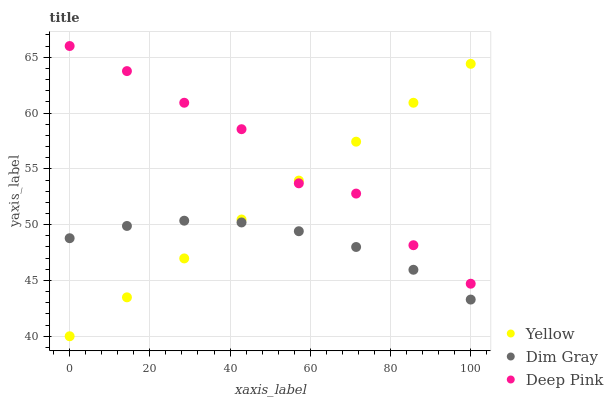Does Dim Gray have the minimum area under the curve?
Answer yes or no. Yes. Does Deep Pink have the maximum area under the curve?
Answer yes or no. Yes. Does Yellow have the minimum area under the curve?
Answer yes or no. No. Does Yellow have the maximum area under the curve?
Answer yes or no. No. Is Yellow the smoothest?
Answer yes or no. Yes. Is Deep Pink the roughest?
Answer yes or no. Yes. Is Deep Pink the smoothest?
Answer yes or no. No. Is Yellow the roughest?
Answer yes or no. No. Does Yellow have the lowest value?
Answer yes or no. Yes. Does Deep Pink have the lowest value?
Answer yes or no. No. Does Deep Pink have the highest value?
Answer yes or no. Yes. Does Yellow have the highest value?
Answer yes or no. No. Is Dim Gray less than Deep Pink?
Answer yes or no. Yes. Is Deep Pink greater than Dim Gray?
Answer yes or no. Yes. Does Dim Gray intersect Yellow?
Answer yes or no. Yes. Is Dim Gray less than Yellow?
Answer yes or no. No. Is Dim Gray greater than Yellow?
Answer yes or no. No. Does Dim Gray intersect Deep Pink?
Answer yes or no. No. 